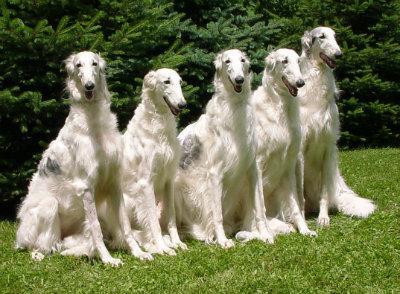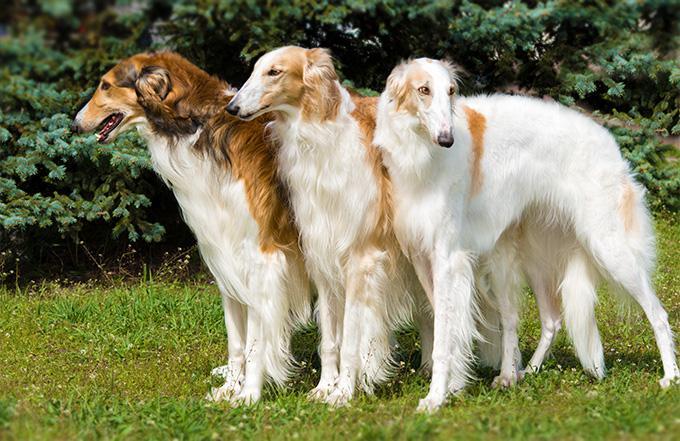The first image is the image on the left, the second image is the image on the right. Assess this claim about the two images: "There is exactly one dog in each image.". Correct or not? Answer yes or no. No. The first image is the image on the left, the second image is the image on the right. Evaluate the accuracy of this statement regarding the images: "There are at least two dogs in the image on the left.". Is it true? Answer yes or no. Yes. 